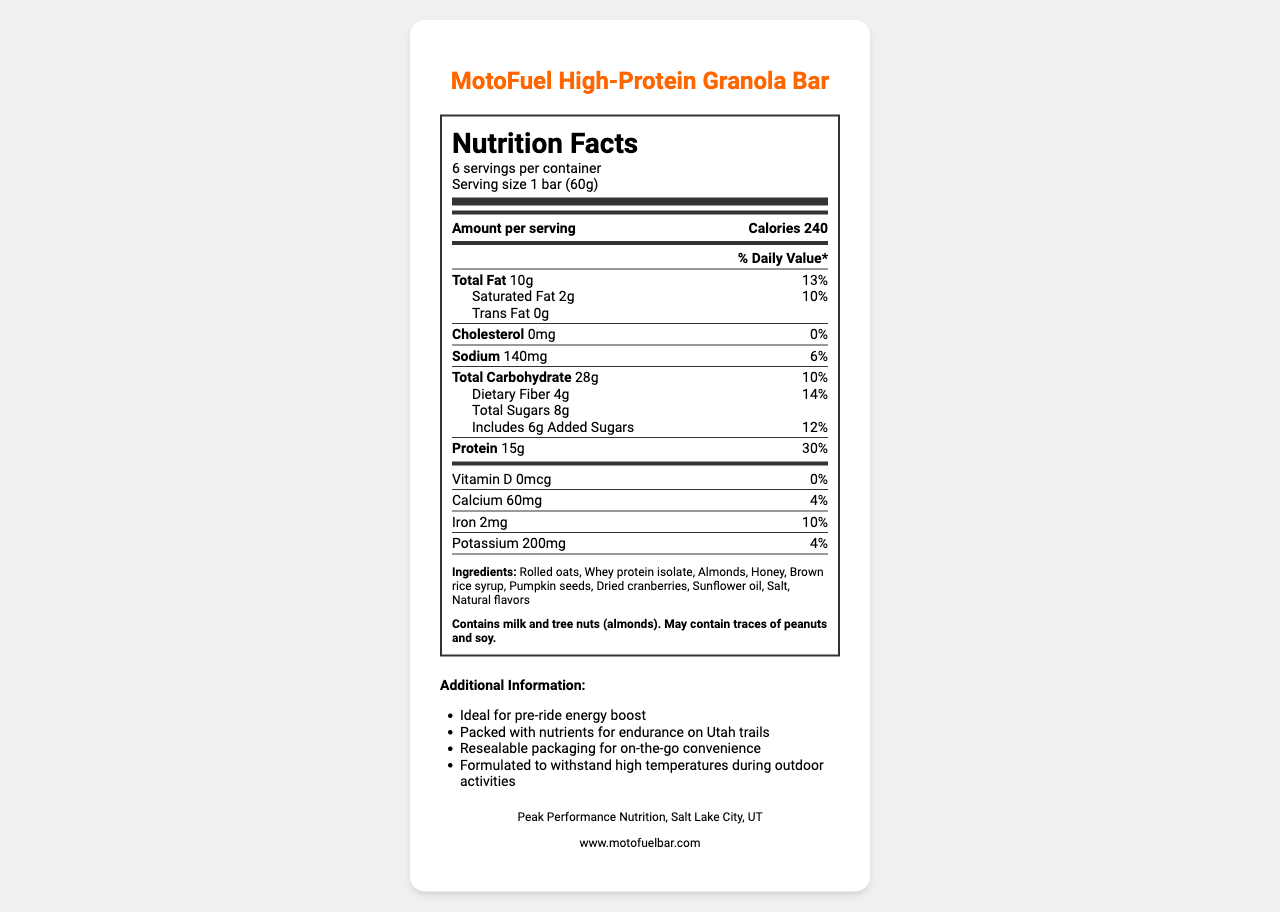what is the serving size of the MotoFuel High-Protein Granola Bar? The serving size is specified in the nutrition facts label as "Serving size 1 bar (60g)."
Answer: 1 bar (60g) how many calories are there per serving? The nutrition facts label indicates that there are 240 calories per serving.
Answer: 240 how much protein is in one serving of the granola bar? The label shows that one serving contains 15g of protein.
Answer: 15g what is the percentage of daily value for dietary fiber? The daily value percentage for dietary fiber is listed as 14% on the nutrition facts label.
Answer: 14% which ingredient is the primary source of protein in the bar? Whey protein isolate is one of the listed ingredients and is a known primary source of protein.
Answer: Whey protein isolate how much total fat is in one bar? A. 5g B. 10g C. 15g The nutrition facts label states that there are 10g of total fat per serving.
Answer: B how much sodium does one serving contain? A. 120mg B. 140mg C. 160mg D. 180mg The label indicates that there is 140mg of sodium per serving.
Answer: B does this product contain any trans fat? The nutrition facts label shows "Trans Fat 0g," meaning it does not contain trans fat.
Answer: No is this granola bar suitable for someone with a peanut allergy? The allergen information states that it "May contain traces of peanuts and soy," making it unsuitable for someone with a peanut allergy.
Answer: No summarize the main nutritional benefits of the MotoFuel High-Protein Granola Bar. The granola bar provides high protein (15g per serving) and dietary fiber (4g, 14% daily value), with moderate calorie content (240 calories) and no cholesterol.
Answer: High in protein and dietary fiber with moderate calories and low cholesterol what is the manufacturing company of this product? The manufacturer information at the bottom of the document reveals that the product is made by Peak Performance Nutrition.
Answer: Peak Performance Nutrition can you determine the price of the MotoFuel High-Protein Granola Bar from the document? The document does not provide any information related to the price of the granola bar.
Answer: I don't know 